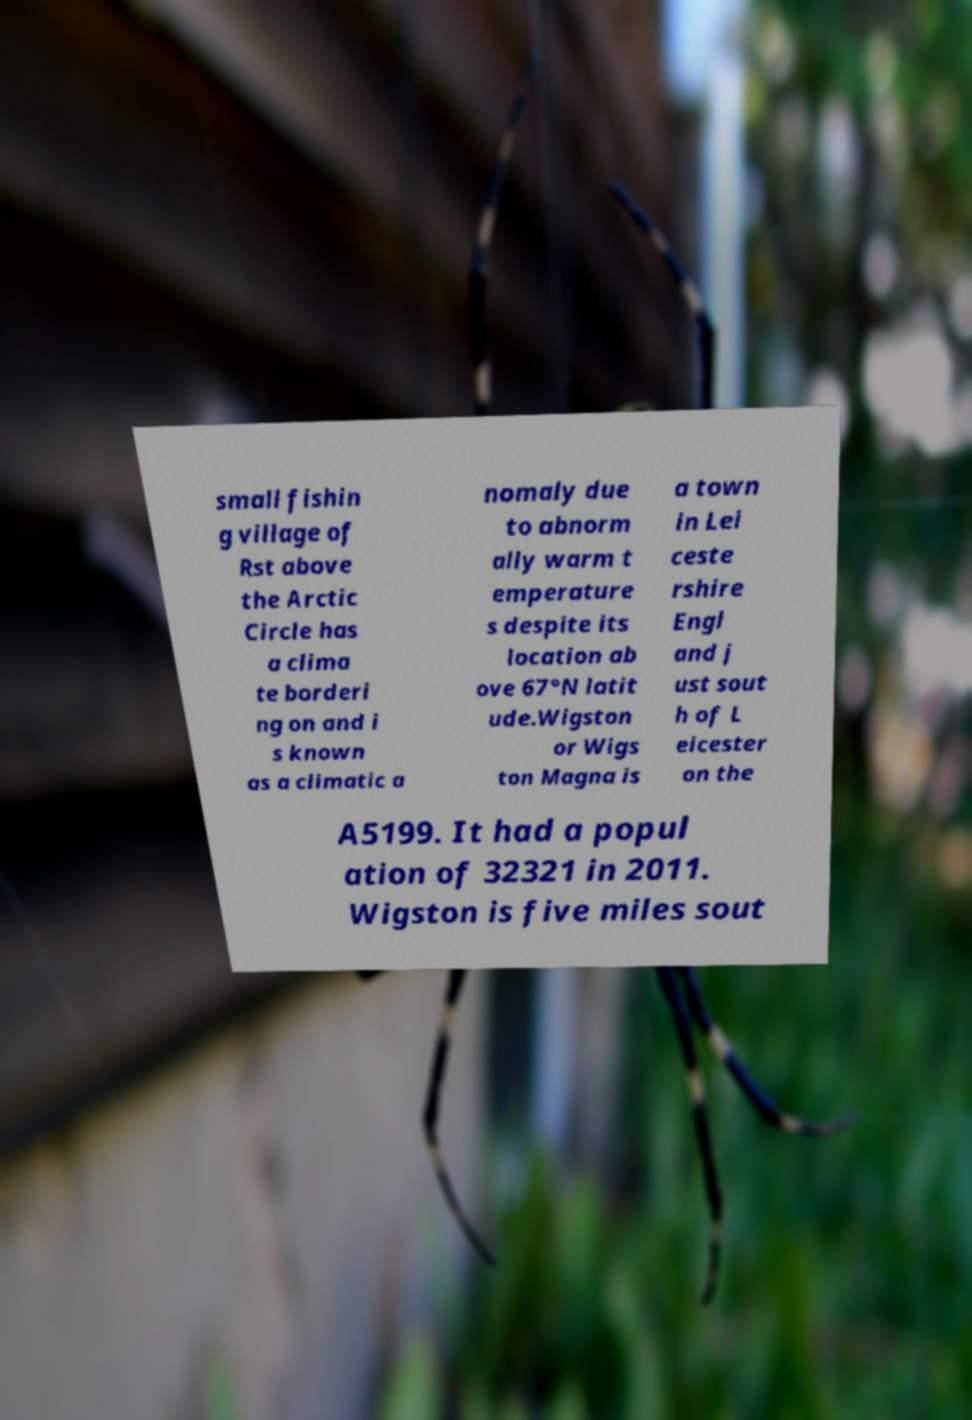Please read and relay the text visible in this image. What does it say? small fishin g village of Rst above the Arctic Circle has a clima te borderi ng on and i s known as a climatic a nomaly due to abnorm ally warm t emperature s despite its location ab ove 67°N latit ude.Wigston or Wigs ton Magna is a town in Lei ceste rshire Engl and j ust sout h of L eicester on the A5199. It had a popul ation of 32321 in 2011. Wigston is five miles sout 